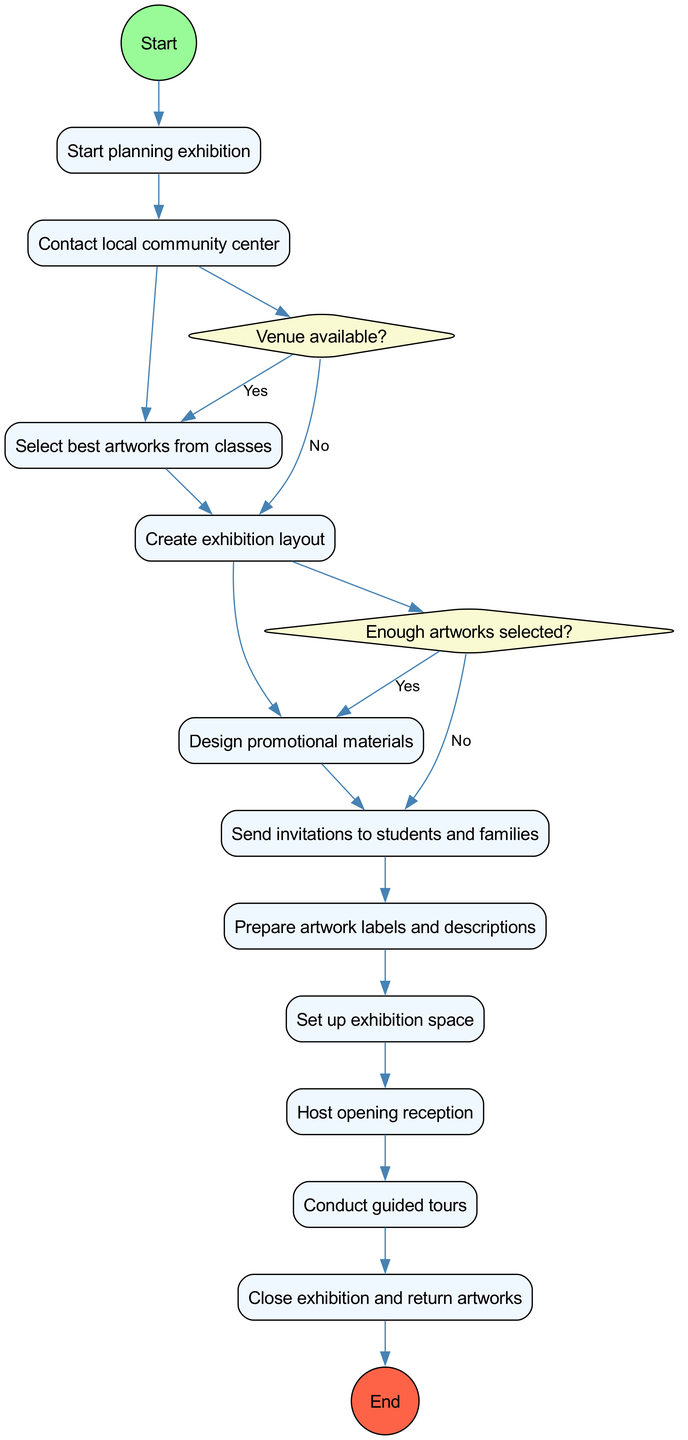What is the initial node in the diagram? The initial node in the diagram is labeled "Start planning exhibition". It represents the first step in the flow of activities for organizing the community art exhibition.
Answer: Start planning exhibition How many activities are there in the diagram? There are eight activities listed in the diagram. Counting each of the specific actions yields a total of eight.
Answer: 8 What decision follows the activity of selecting artworks? The decision that follows the activity of selecting artworks is "Enough artworks selected?". It aims to determine if the selection is adequate before proceeding.
Answer: Enough artworks selected? What happens if the venue is not available? If the venue is not available, the flow indicates that the next action is "Look for alternative location". This is a direct consequence of the decision regarding venue availability.
Answer: Look for alternative location What is the last activity before closing the exhibition? The last activity before closing the exhibition is "Conduct guided tours". This activity occurs shortly before reaching the final node related to closing the exhibition.
Answer: Conduct guided tours How many decision points are there in the diagram? The diagram contains two decision points. They are based on the availability of the venue and the sufficiency of selected artworks.
Answer: 2 What is the final node in the activity diagram? The final node in the activity diagram is labeled "Close exhibition and return artworks". It signifies the completion of the exhibition process and actions taken afterward.
Answer: Close exhibition and return artworks Which activity comes before booking the venue? The activity that comes before booking the venue is "Contact local community center". This is a prerequisite action leading to the venue decision.
Answer: Contact local community center Which activity directly leads to the opening reception? The activity that directly leads to the opening reception is "Set up exhibition space". This setup is essential to hosting the reception that follows.
Answer: Set up exhibition space 